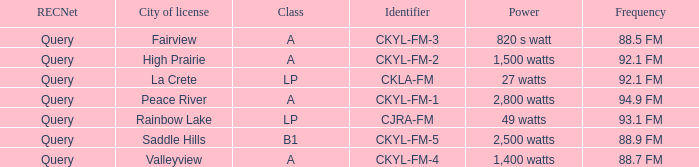What is the city of license that has a 1,400 watts power Valleyview. 